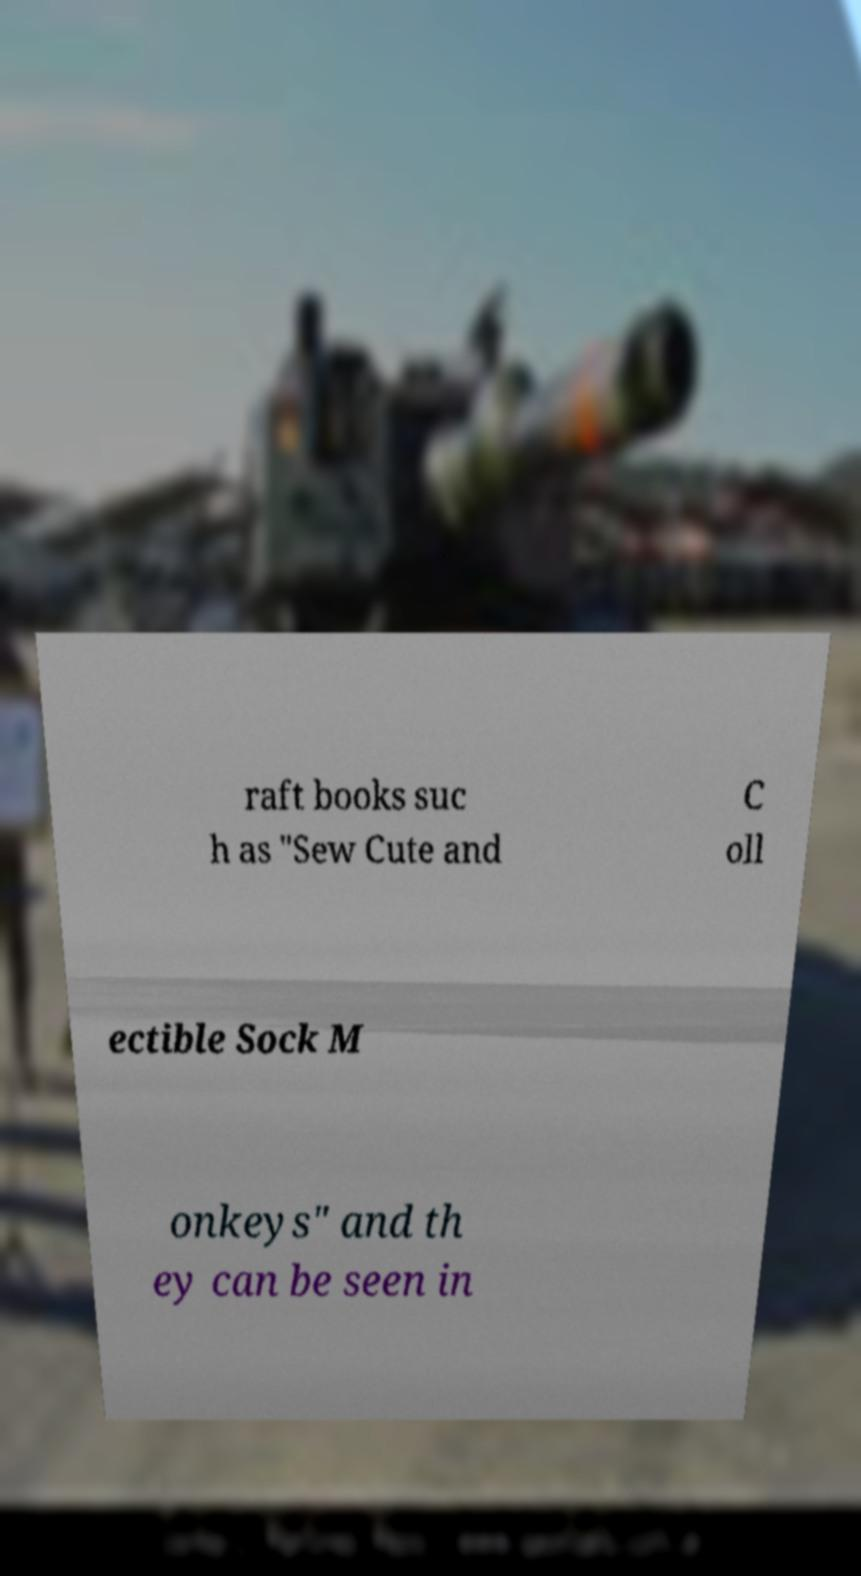I need the written content from this picture converted into text. Can you do that? raft books suc h as "Sew Cute and C oll ectible Sock M onkeys" and th ey can be seen in 